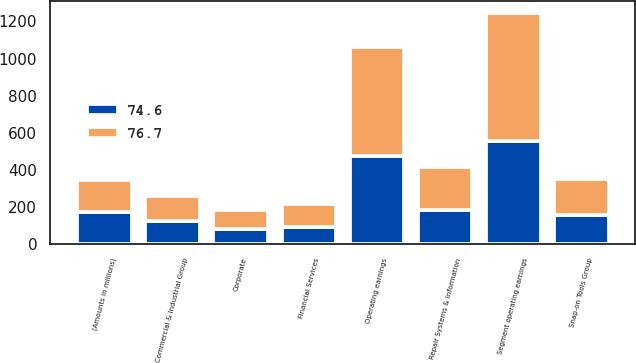Convert chart. <chart><loc_0><loc_0><loc_500><loc_500><stacked_bar_chart><ecel><fcel>(Amounts in millions)<fcel>Commercial & Industrial Group<fcel>Snap-on Tools Group<fcel>Repair Systems & Information<fcel>Financial Services<fcel>Segment operating earnings<fcel>Corporate<fcel>Operating earnings<nl><fcel>76.7<fcel>171.6<fcel>137.3<fcel>194.6<fcel>231.9<fcel>125.7<fcel>689.5<fcel>103.3<fcel>586.2<nl><fcel>74.6<fcel>171.6<fcel>123.4<fcel>158.5<fcel>184.7<fcel>90.9<fcel>557.5<fcel>82.4<fcel>475.1<nl></chart> 